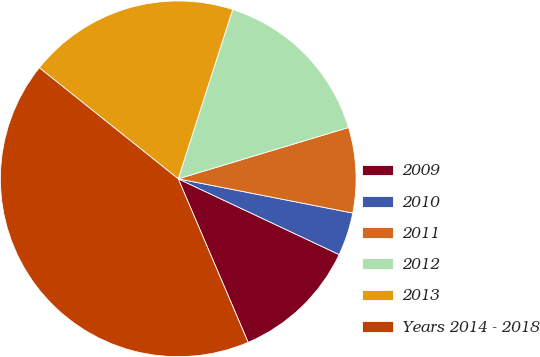Convert chart to OTSL. <chart><loc_0><loc_0><loc_500><loc_500><pie_chart><fcel>2009<fcel>2010<fcel>2011<fcel>2012<fcel>2013<fcel>Years 2014 - 2018<nl><fcel>11.57%<fcel>3.92%<fcel>7.74%<fcel>15.39%<fcel>19.22%<fcel>42.17%<nl></chart> 